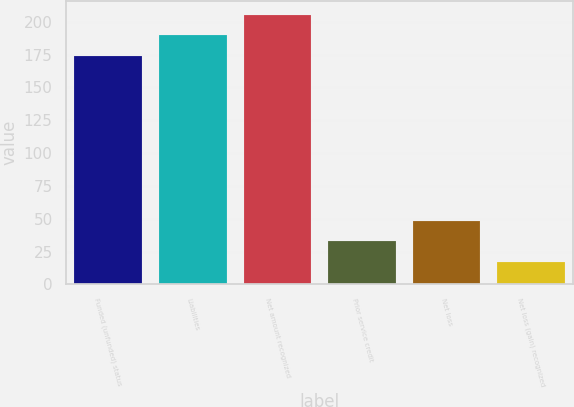Convert chart. <chart><loc_0><loc_0><loc_500><loc_500><bar_chart><fcel>Funded (unfunded) status<fcel>Liabilities<fcel>Net amount recognized<fcel>Prior service credit<fcel>Net loss<fcel>Net loss (gain) recognized<nl><fcel>174<fcel>189.7<fcel>205.4<fcel>32.7<fcel>48.4<fcel>17<nl></chart> 